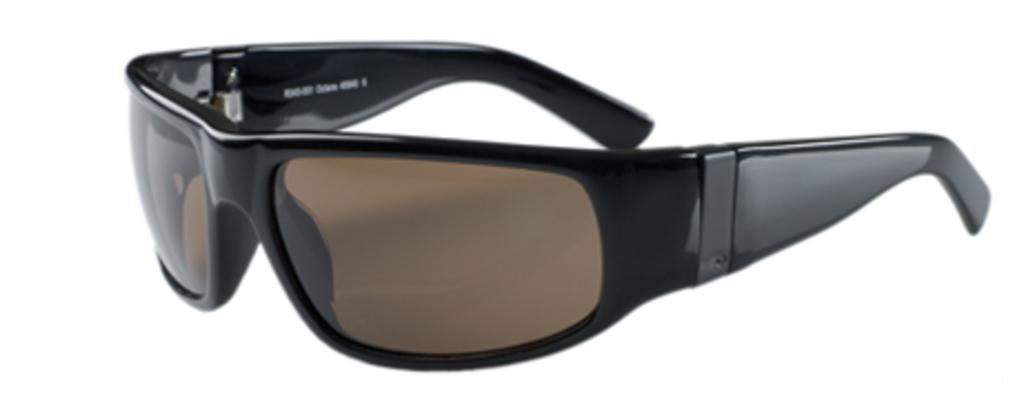What is the main object in the center of the image? There is a pair of goggles in the center of the image. What might the goggles be used for? The goggles might be used for swimming, diving, or other activities that require eye protection. What type of shirt is being worn by the earth in the image? There is no earth or shirt present in the image; it only features a pair of goggles. 